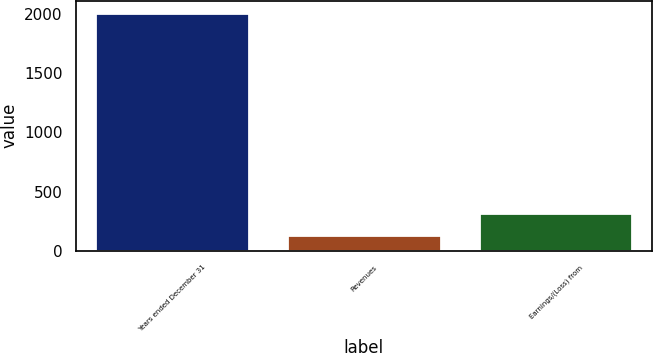Convert chart. <chart><loc_0><loc_0><loc_500><loc_500><bar_chart><fcel>Years ended December 31<fcel>Revenues<fcel>Earnings/(Loss) from<nl><fcel>2012<fcel>133<fcel>320.9<nl></chart> 